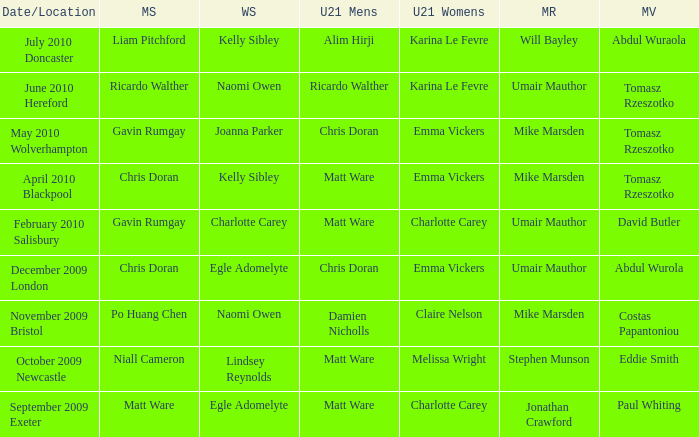Who was the U21 Mens winner when Mike Marsden was the mixed restricted winner and Claire Nelson was the U21 Womens winner?  Damien Nicholls. 